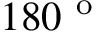<formula> <loc_0><loc_0><loc_500><loc_500>1 8 0 ^ { o }</formula> 